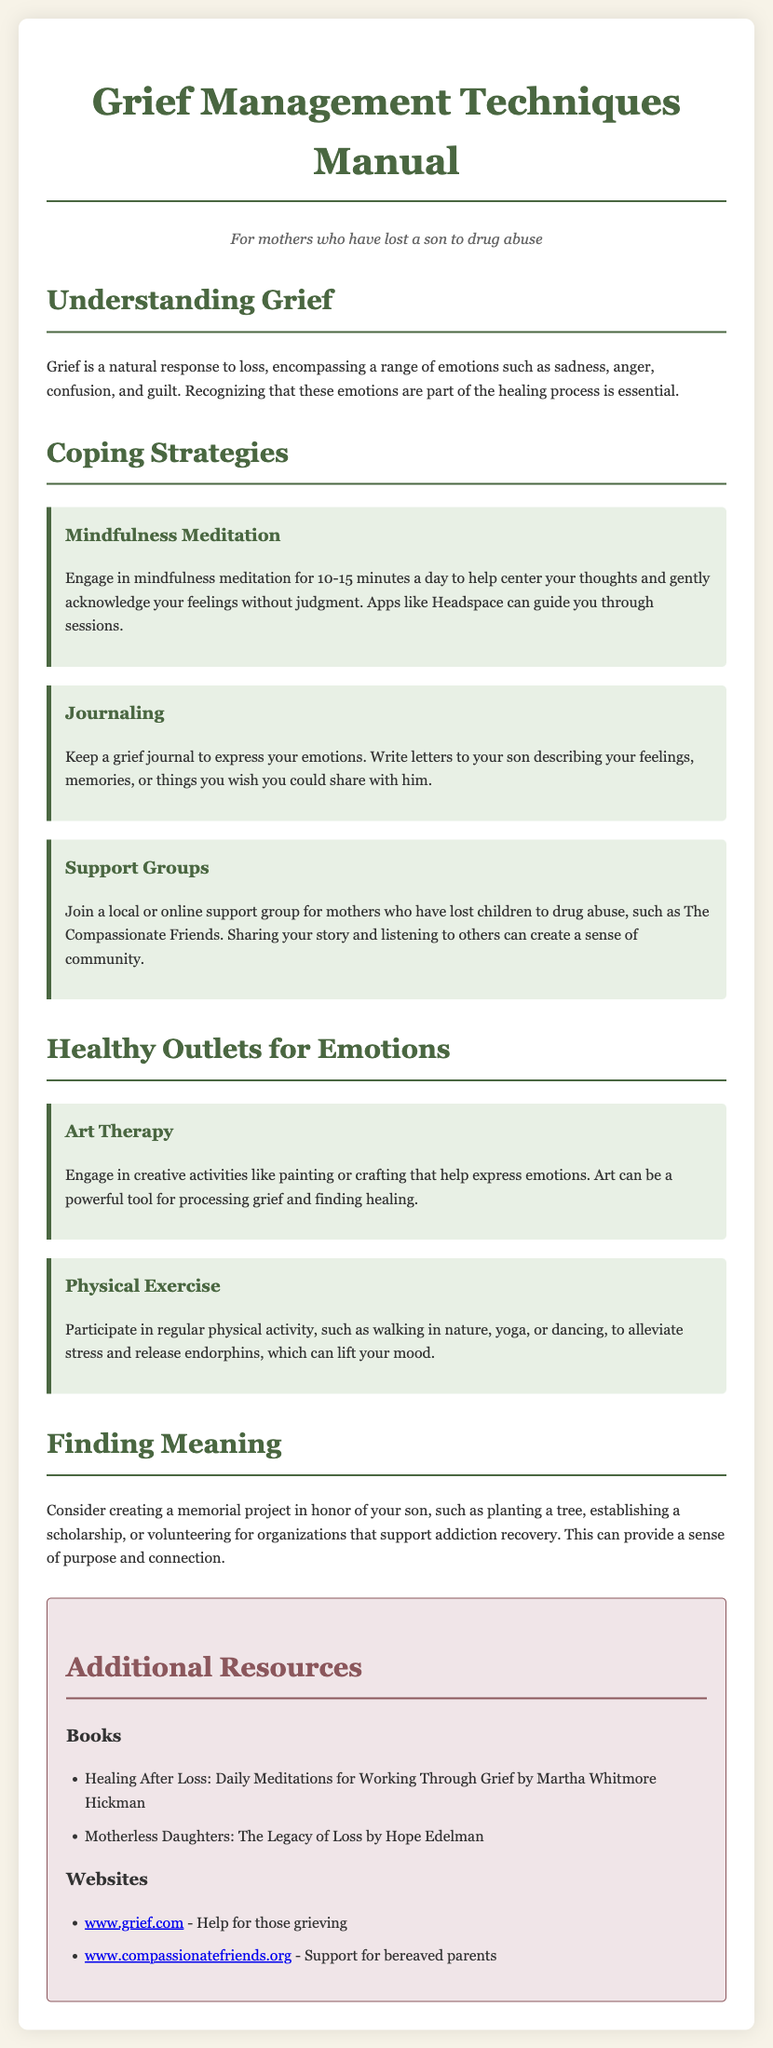what is the title of the manual? The title of the manual is prominently displayed at the top of the document.
Answer: Grief Management Techniques Manual who is the target audience for this manual? The target audience is noted in a descriptive line beneath the title.
Answer: For mothers who have lost a son to drug abuse how many coping strategies are listed in the document? The document lists three distinct coping strategies.
Answer: 3 what is one suggested healthy outlet for emotions? The document provides two activities under healthy outlets for emotions, mentioning one as an example.
Answer: Art Therapy which book is recommended in the additional resources section? The document includes titles in the resources section that provide further reading.
Answer: Healing After Loss: Daily Meditations for Working Through Grief by Martha Whitmore Hickman what type of project is suggested to find meaning after loss? The document suggests creating a project as a way to find meaning, which is noted under a specific section.
Answer: memorial project explain the purpose of mindfulness meditation as outlined in the manual. The document describes mindfulness meditation as a practice to help with emotional acknowledgment.
Answer: center your thoughts and gently acknowledge your feelings without judgment what activity is recommended for physical exercise? The document mentions various forms of physical activity, specifically noting one example.
Answer: yoga 